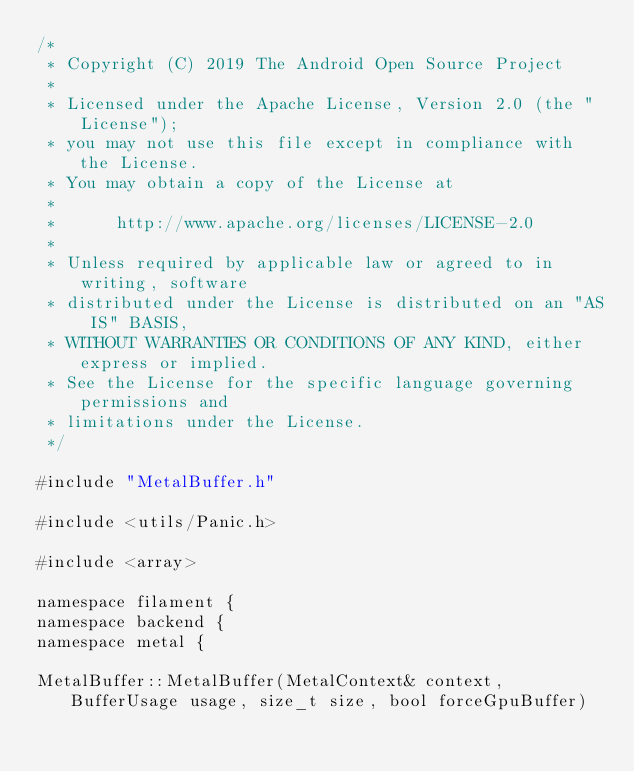<code> <loc_0><loc_0><loc_500><loc_500><_ObjectiveC_>/*
 * Copyright (C) 2019 The Android Open Source Project
 *
 * Licensed under the Apache License, Version 2.0 (the "License");
 * you may not use this file except in compliance with the License.
 * You may obtain a copy of the License at
 *
 *      http://www.apache.org/licenses/LICENSE-2.0
 *
 * Unless required by applicable law or agreed to in writing, software
 * distributed under the License is distributed on an "AS IS" BASIS,
 * WITHOUT WARRANTIES OR CONDITIONS OF ANY KIND, either express or implied.
 * See the License for the specific language governing permissions and
 * limitations under the License.
 */

#include "MetalBuffer.h"

#include <utils/Panic.h>

#include <array>

namespace filament {
namespace backend {
namespace metal {

MetalBuffer::MetalBuffer(MetalContext& context, BufferUsage usage, size_t size, bool forceGpuBuffer)</code> 